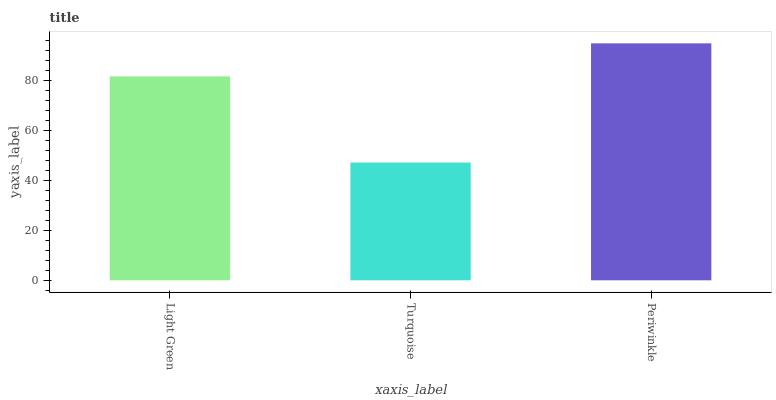Is Periwinkle the minimum?
Answer yes or no. No. Is Turquoise the maximum?
Answer yes or no. No. Is Periwinkle greater than Turquoise?
Answer yes or no. Yes. Is Turquoise less than Periwinkle?
Answer yes or no. Yes. Is Turquoise greater than Periwinkle?
Answer yes or no. No. Is Periwinkle less than Turquoise?
Answer yes or no. No. Is Light Green the high median?
Answer yes or no. Yes. Is Light Green the low median?
Answer yes or no. Yes. Is Periwinkle the high median?
Answer yes or no. No. Is Periwinkle the low median?
Answer yes or no. No. 